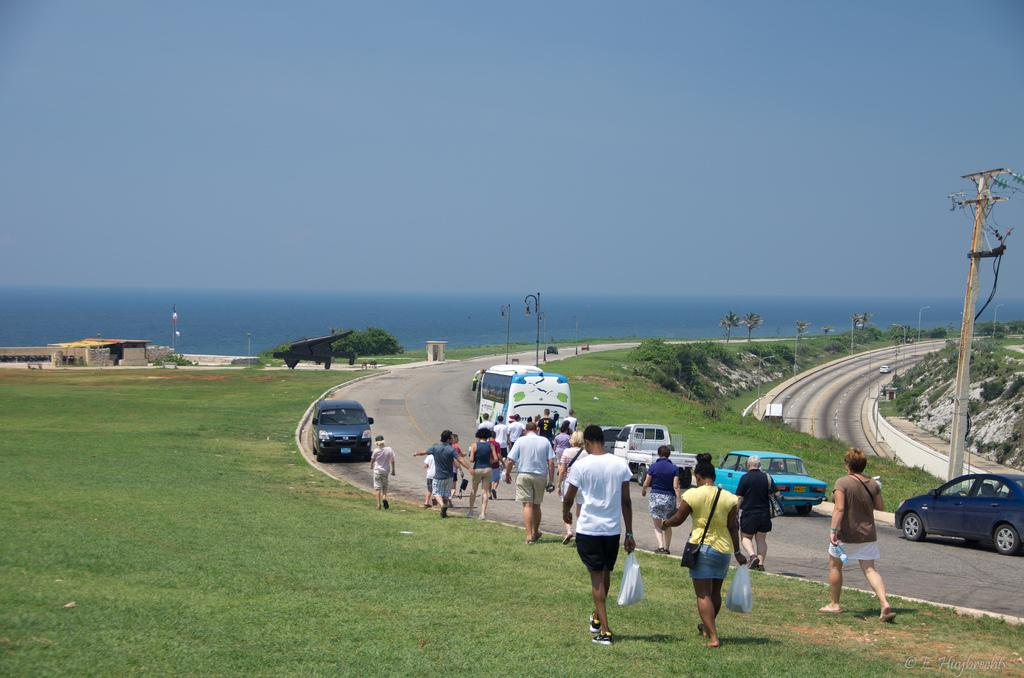What is the main subject of the image? The main subject of the image is a crowd. What are the people in the crowd doing? The crowd is walking on the ground and road. What structures can be seen in the image? Street poles and street lights are visible in the image. What can be seen in the background of the image? In the background, there is a road, hills, trees, buildings, water, and the sea. How many legs can be seen on the bears in the image? There are no bears present in the image, so it is not possible to determine the number of legs on any bears. 